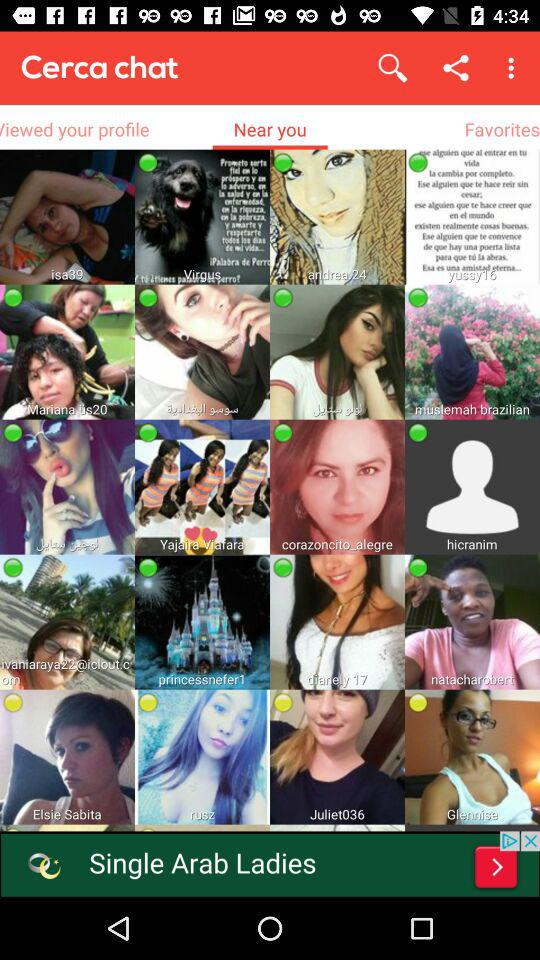Which tab am I using? You are using the "Near you" tab. 